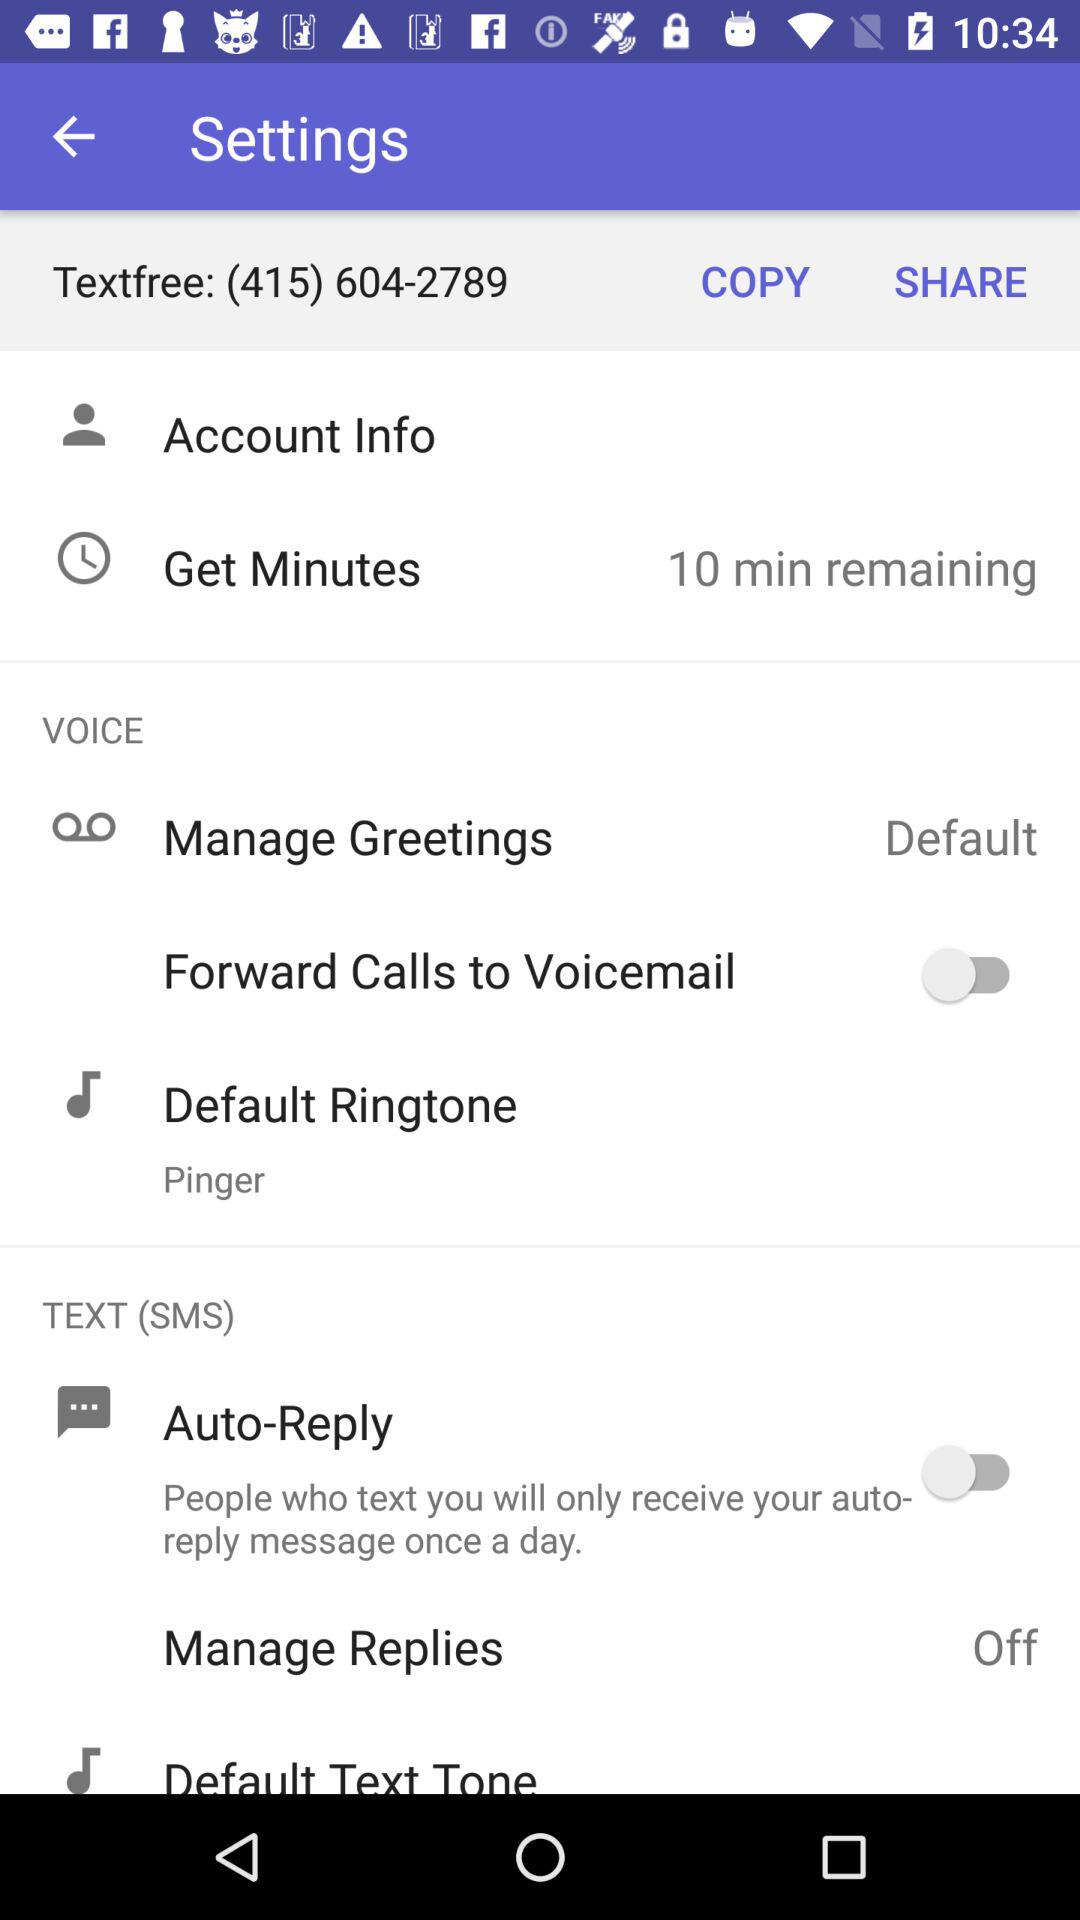What is the status of the "Manage Replies"? The status of the "Manage Replies" is "off". 